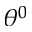<formula> <loc_0><loc_0><loc_500><loc_500>\theta ^ { 0 }</formula> 